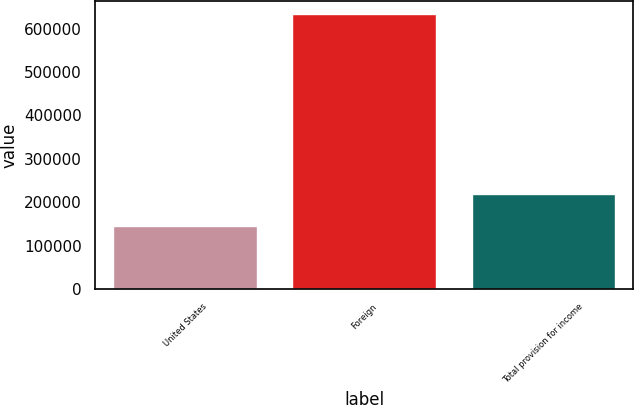Convert chart. <chart><loc_0><loc_0><loc_500><loc_500><bar_chart><fcel>United States<fcel>Foreign<fcel>Total provision for income<nl><fcel>145856<fcel>632985<fcel>219333<nl></chart> 